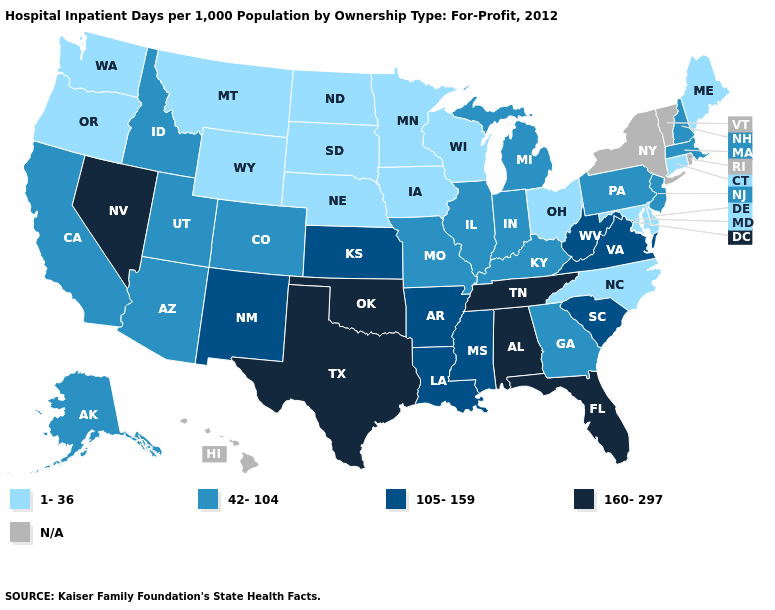What is the value of Montana?
Give a very brief answer. 1-36. Name the states that have a value in the range N/A?
Quick response, please. Hawaii, New York, Rhode Island, Vermont. What is the value of Alaska?
Quick response, please. 42-104. Is the legend a continuous bar?
Keep it brief. No. Does Massachusetts have the highest value in the USA?
Short answer required. No. Which states have the lowest value in the USA?
Write a very short answer. Connecticut, Delaware, Iowa, Maine, Maryland, Minnesota, Montana, Nebraska, North Carolina, North Dakota, Ohio, Oregon, South Dakota, Washington, Wisconsin, Wyoming. Among the states that border Texas , does Arkansas have the lowest value?
Concise answer only. Yes. What is the value of Delaware?
Short answer required. 1-36. What is the value of Utah?
Give a very brief answer. 42-104. Among the states that border Mississippi , which have the lowest value?
Give a very brief answer. Arkansas, Louisiana. Among the states that border Mississippi , does Tennessee have the lowest value?
Keep it brief. No. Name the states that have a value in the range N/A?
Concise answer only. Hawaii, New York, Rhode Island, Vermont. What is the value of Vermont?
Write a very short answer. N/A. 